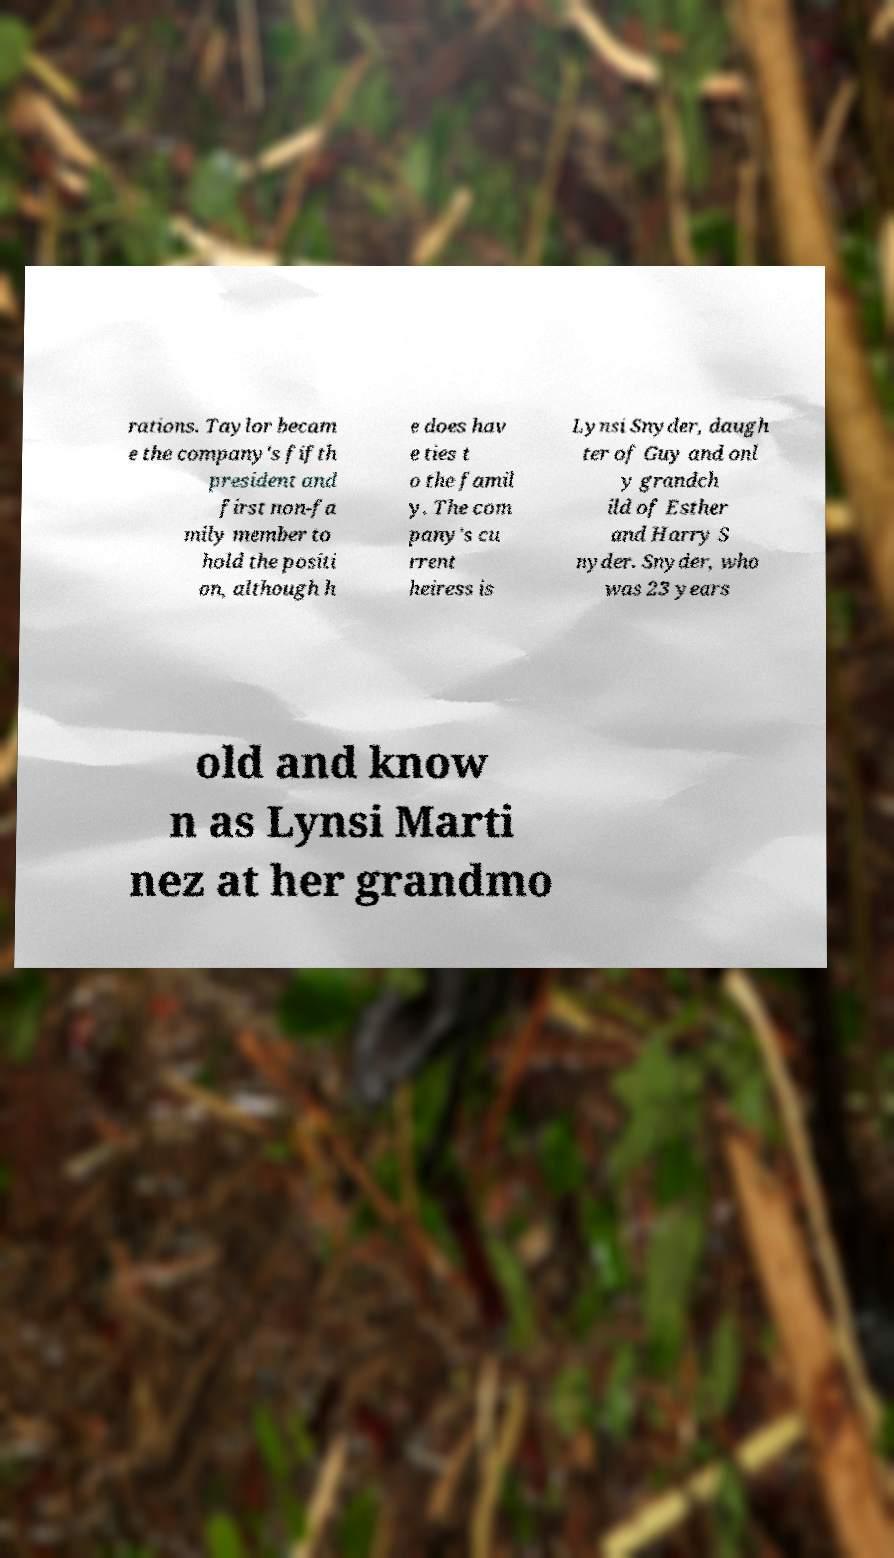Can you read and provide the text displayed in the image?This photo seems to have some interesting text. Can you extract and type it out for me? rations. Taylor becam e the company's fifth president and first non-fa mily member to hold the positi on, although h e does hav e ties t o the famil y. The com pany's cu rrent heiress is Lynsi Snyder, daugh ter of Guy and onl y grandch ild of Esther and Harry S nyder. Snyder, who was 23 years old and know n as Lynsi Marti nez at her grandmo 